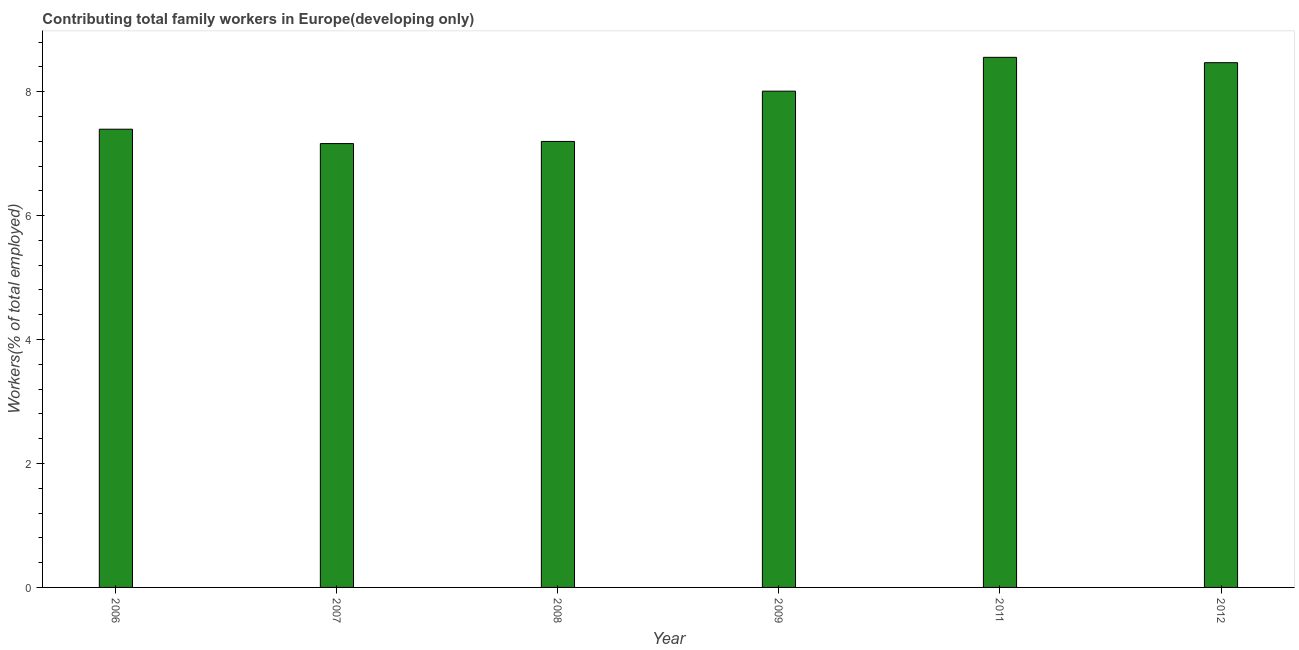What is the title of the graph?
Ensure brevity in your answer.  Contributing total family workers in Europe(developing only). What is the label or title of the Y-axis?
Make the answer very short. Workers(% of total employed). What is the contributing family workers in 2006?
Make the answer very short. 7.39. Across all years, what is the maximum contributing family workers?
Your answer should be very brief. 8.55. Across all years, what is the minimum contributing family workers?
Keep it short and to the point. 7.16. In which year was the contributing family workers maximum?
Provide a succinct answer. 2011. What is the sum of the contributing family workers?
Provide a short and direct response. 46.78. What is the difference between the contributing family workers in 2007 and 2009?
Ensure brevity in your answer.  -0.85. What is the average contributing family workers per year?
Your answer should be very brief. 7.8. What is the median contributing family workers?
Your answer should be compact. 7.7. In how many years, is the contributing family workers greater than 7.6 %?
Your answer should be very brief. 3. Do a majority of the years between 2009 and 2006 (inclusive) have contributing family workers greater than 8 %?
Your answer should be compact. Yes. What is the ratio of the contributing family workers in 2006 to that in 2009?
Provide a succinct answer. 0.92. Is the contributing family workers in 2008 less than that in 2011?
Offer a very short reply. Yes. What is the difference between the highest and the second highest contributing family workers?
Offer a terse response. 0.09. What is the difference between the highest and the lowest contributing family workers?
Keep it short and to the point. 1.39. In how many years, is the contributing family workers greater than the average contributing family workers taken over all years?
Your answer should be very brief. 3. How many bars are there?
Offer a very short reply. 6. Are all the bars in the graph horizontal?
Make the answer very short. No. How many years are there in the graph?
Offer a very short reply. 6. What is the difference between two consecutive major ticks on the Y-axis?
Offer a terse response. 2. What is the Workers(% of total employed) of 2006?
Make the answer very short. 7.39. What is the Workers(% of total employed) in 2007?
Your response must be concise. 7.16. What is the Workers(% of total employed) of 2008?
Keep it short and to the point. 7.2. What is the Workers(% of total employed) in 2009?
Give a very brief answer. 8.01. What is the Workers(% of total employed) of 2011?
Make the answer very short. 8.55. What is the Workers(% of total employed) in 2012?
Your answer should be compact. 8.47. What is the difference between the Workers(% of total employed) in 2006 and 2007?
Your answer should be very brief. 0.23. What is the difference between the Workers(% of total employed) in 2006 and 2008?
Offer a terse response. 0.2. What is the difference between the Workers(% of total employed) in 2006 and 2009?
Your answer should be compact. -0.61. What is the difference between the Workers(% of total employed) in 2006 and 2011?
Keep it short and to the point. -1.16. What is the difference between the Workers(% of total employed) in 2006 and 2012?
Provide a short and direct response. -1.07. What is the difference between the Workers(% of total employed) in 2007 and 2008?
Your answer should be compact. -0.03. What is the difference between the Workers(% of total employed) in 2007 and 2009?
Your response must be concise. -0.85. What is the difference between the Workers(% of total employed) in 2007 and 2011?
Make the answer very short. -1.39. What is the difference between the Workers(% of total employed) in 2007 and 2012?
Your response must be concise. -1.31. What is the difference between the Workers(% of total employed) in 2008 and 2009?
Provide a succinct answer. -0.81. What is the difference between the Workers(% of total employed) in 2008 and 2011?
Your answer should be compact. -1.36. What is the difference between the Workers(% of total employed) in 2008 and 2012?
Offer a very short reply. -1.27. What is the difference between the Workers(% of total employed) in 2009 and 2011?
Ensure brevity in your answer.  -0.55. What is the difference between the Workers(% of total employed) in 2009 and 2012?
Give a very brief answer. -0.46. What is the difference between the Workers(% of total employed) in 2011 and 2012?
Make the answer very short. 0.09. What is the ratio of the Workers(% of total employed) in 2006 to that in 2007?
Your answer should be compact. 1.03. What is the ratio of the Workers(% of total employed) in 2006 to that in 2009?
Provide a succinct answer. 0.92. What is the ratio of the Workers(% of total employed) in 2006 to that in 2011?
Your answer should be compact. 0.86. What is the ratio of the Workers(% of total employed) in 2006 to that in 2012?
Provide a short and direct response. 0.87. What is the ratio of the Workers(% of total employed) in 2007 to that in 2008?
Your answer should be compact. 0.99. What is the ratio of the Workers(% of total employed) in 2007 to that in 2009?
Provide a succinct answer. 0.89. What is the ratio of the Workers(% of total employed) in 2007 to that in 2011?
Keep it short and to the point. 0.84. What is the ratio of the Workers(% of total employed) in 2007 to that in 2012?
Your answer should be compact. 0.85. What is the ratio of the Workers(% of total employed) in 2008 to that in 2009?
Provide a succinct answer. 0.9. What is the ratio of the Workers(% of total employed) in 2008 to that in 2011?
Give a very brief answer. 0.84. What is the ratio of the Workers(% of total employed) in 2009 to that in 2011?
Your answer should be compact. 0.94. What is the ratio of the Workers(% of total employed) in 2009 to that in 2012?
Offer a terse response. 0.95. 